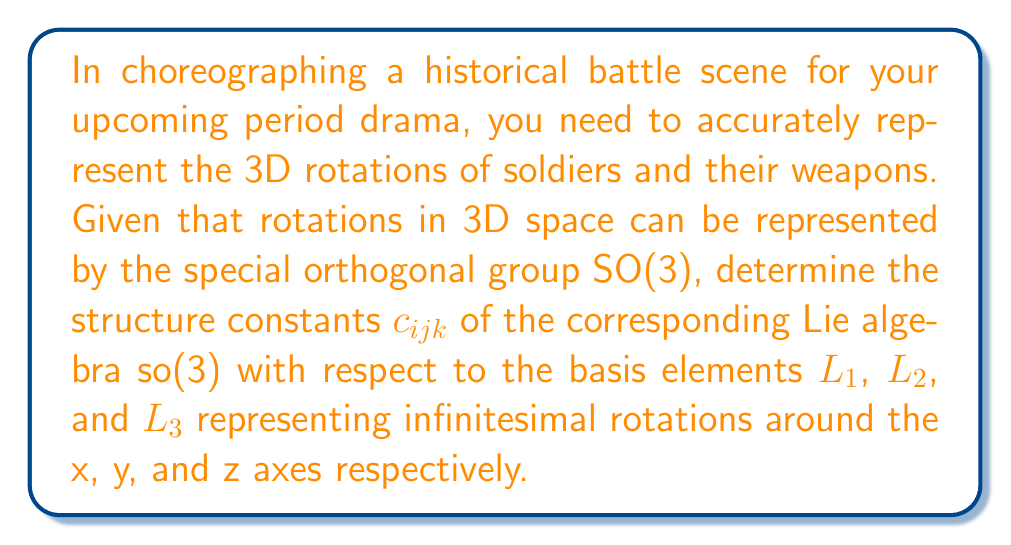Help me with this question. To determine the Lie algebra structure of rotations in 3D space, we need to follow these steps:

1) First, recall that the Lie algebra so(3) consists of 3x3 skew-symmetric matrices. The basis elements $L_1$, $L_2$, and $L_3$ can be represented as:

   $$L_1 = \begin{pmatrix}
   0 & 0 & 0 \\
   0 & 0 & -1 \\
   0 & 1 & 0
   \end{pmatrix}, \quad
   L_2 = \begin{pmatrix}
   0 & 0 & 1 \\
   0 & 0 & 0 \\
   -1 & 0 & 0
   \end{pmatrix}, \quad
   L_3 = \begin{pmatrix}
   0 & -1 & 0 \\
   1 & 0 & 0 \\
   0 & 0 & 0
   \end{pmatrix}$$

2) The Lie bracket operation [,] for matrices is defined as $[A,B] = AB - BA$. We need to compute $[L_i, L_j]$ for all pairs $(i,j)$ where $i,j \in \{1,2,3\}$.

3) Let's calculate $[L_1, L_2]$:

   $$[L_1, L_2] = L_1L_2 - L_2L_1 = \begin{pmatrix}
   0 & -1 & 0 \\
   1 & 0 & 0 \\
   0 & 0 & 0
   \end{pmatrix} = L_3$$

4) Similarly, we can calculate:
   
   $$[L_2, L_3] = L_1$$
   $$[L_3, L_1] = L_2$$

5) The structure constants $c_{ijk}$ are defined by the equation:

   $$[L_i, L_j] = \sum_{k=1}^3 c_{ijk}L_k$$

6) Comparing our results with this equation, we can see that:

   $c_{123} = 1$, $c_{231} = 1$, $c_{312} = 1$

   All other $c_{ijk}$ are zero.

7) These structure constants satisfy the property $c_{ijk} = -c_{jik}$ (antisymmetry) and the Jacobi identity.

This Lie algebra structure corresponds to the cross product in 3D space, which is crucial for understanding rotations in your battle scene choreography.
Answer: The non-zero structure constants of the Lie algebra so(3) are:

$c_{123} = c_{231} = c_{312} = 1$
$c_{132} = c_{213} = c_{321} = -1$

All other $c_{ijk} = 0$ 